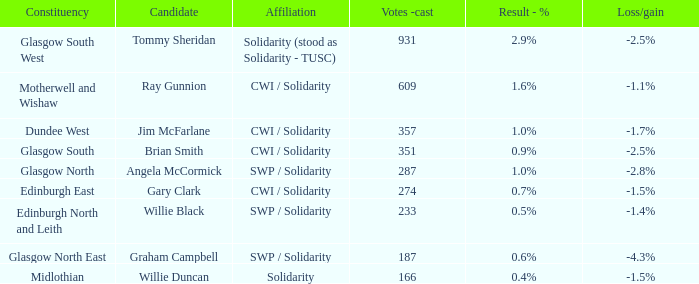What was the loss or gain when the association was united? -1.5%. 